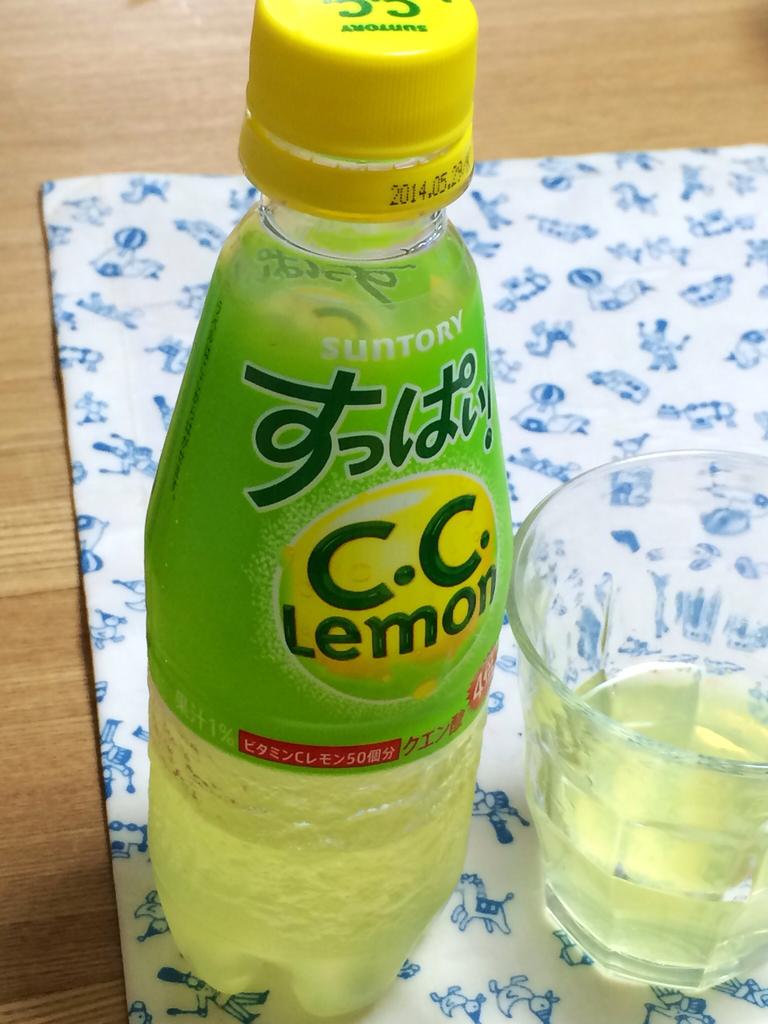Why type of liquid is in the bottle?
Your response must be concise. Lemon. What year was this made?
Offer a terse response. 2014. 